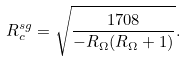<formula> <loc_0><loc_0><loc_500><loc_500>R _ { c } ^ { s g } = \sqrt { \frac { 1 7 0 8 } { - R _ { \Omega } ( R _ { \Omega } + 1 ) } } .</formula> 